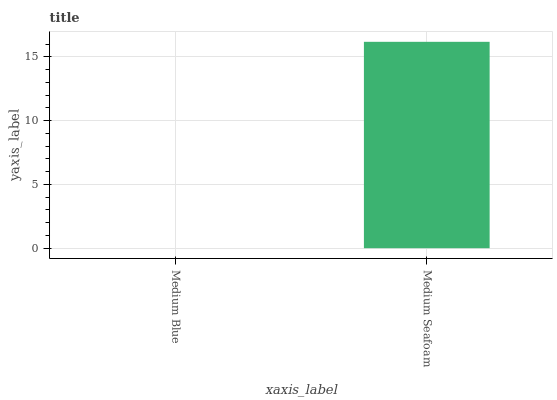Is Medium Blue the minimum?
Answer yes or no. Yes. Is Medium Seafoam the maximum?
Answer yes or no. Yes. Is Medium Seafoam the minimum?
Answer yes or no. No. Is Medium Seafoam greater than Medium Blue?
Answer yes or no. Yes. Is Medium Blue less than Medium Seafoam?
Answer yes or no. Yes. Is Medium Blue greater than Medium Seafoam?
Answer yes or no. No. Is Medium Seafoam less than Medium Blue?
Answer yes or no. No. Is Medium Seafoam the high median?
Answer yes or no. Yes. Is Medium Blue the low median?
Answer yes or no. Yes. Is Medium Blue the high median?
Answer yes or no. No. Is Medium Seafoam the low median?
Answer yes or no. No. 